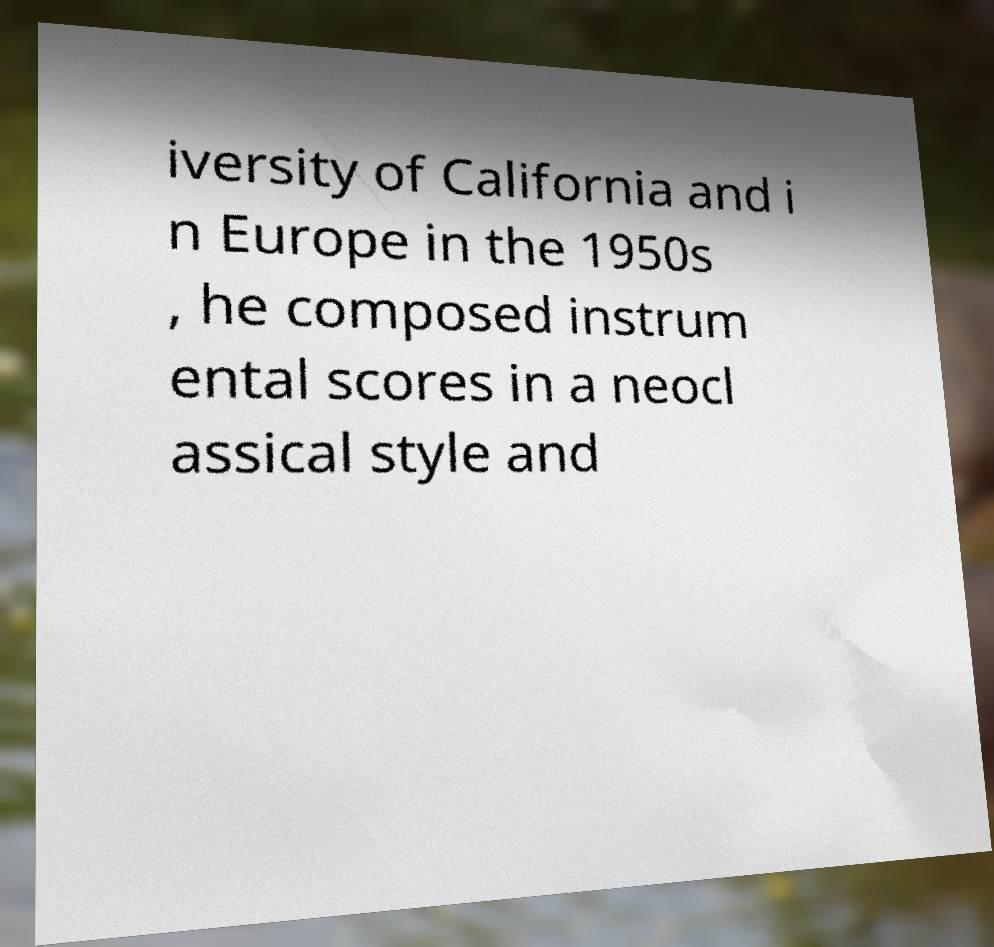There's text embedded in this image that I need extracted. Can you transcribe it verbatim? iversity of California and i n Europe in the 1950s , he composed instrum ental scores in a neocl assical style and 